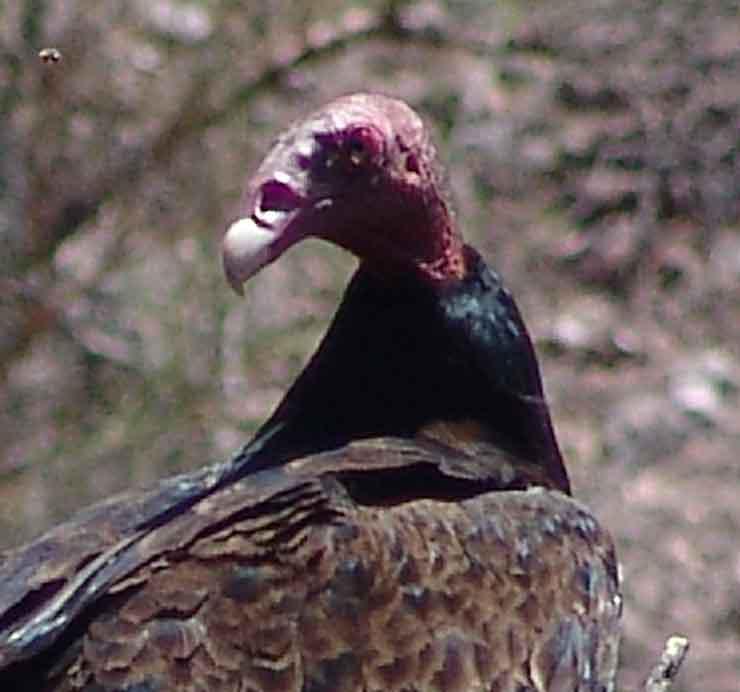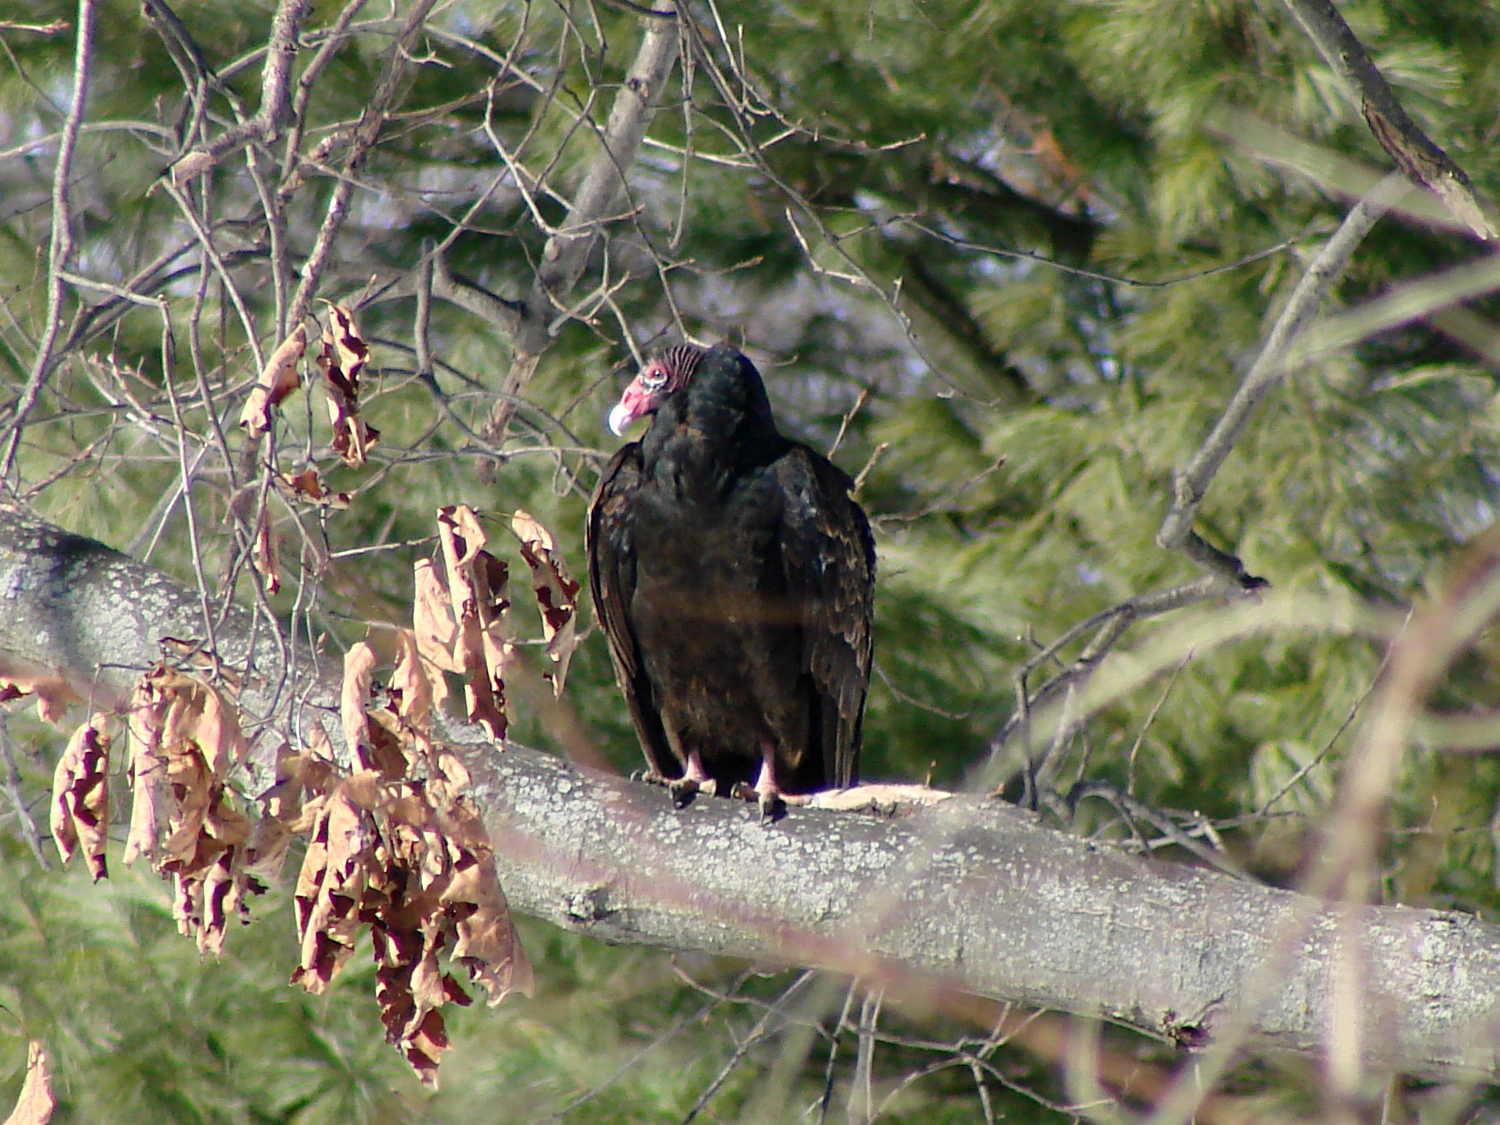The first image is the image on the left, the second image is the image on the right. Considering the images on both sides, is "An image shows one vulture perched on a wooden limb." valid? Answer yes or no. Yes. The first image is the image on the left, the second image is the image on the right. Analyze the images presented: Is the assertion "At least one buzzard is standing on a dead animal in one of the images." valid? Answer yes or no. No. 